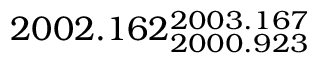<formula> <loc_0><loc_0><loc_500><loc_500>2 0 0 2 . 1 6 2 _ { 2 0 0 0 . 9 2 3 } ^ { 2 0 0 3 . 1 6 7 }</formula> 